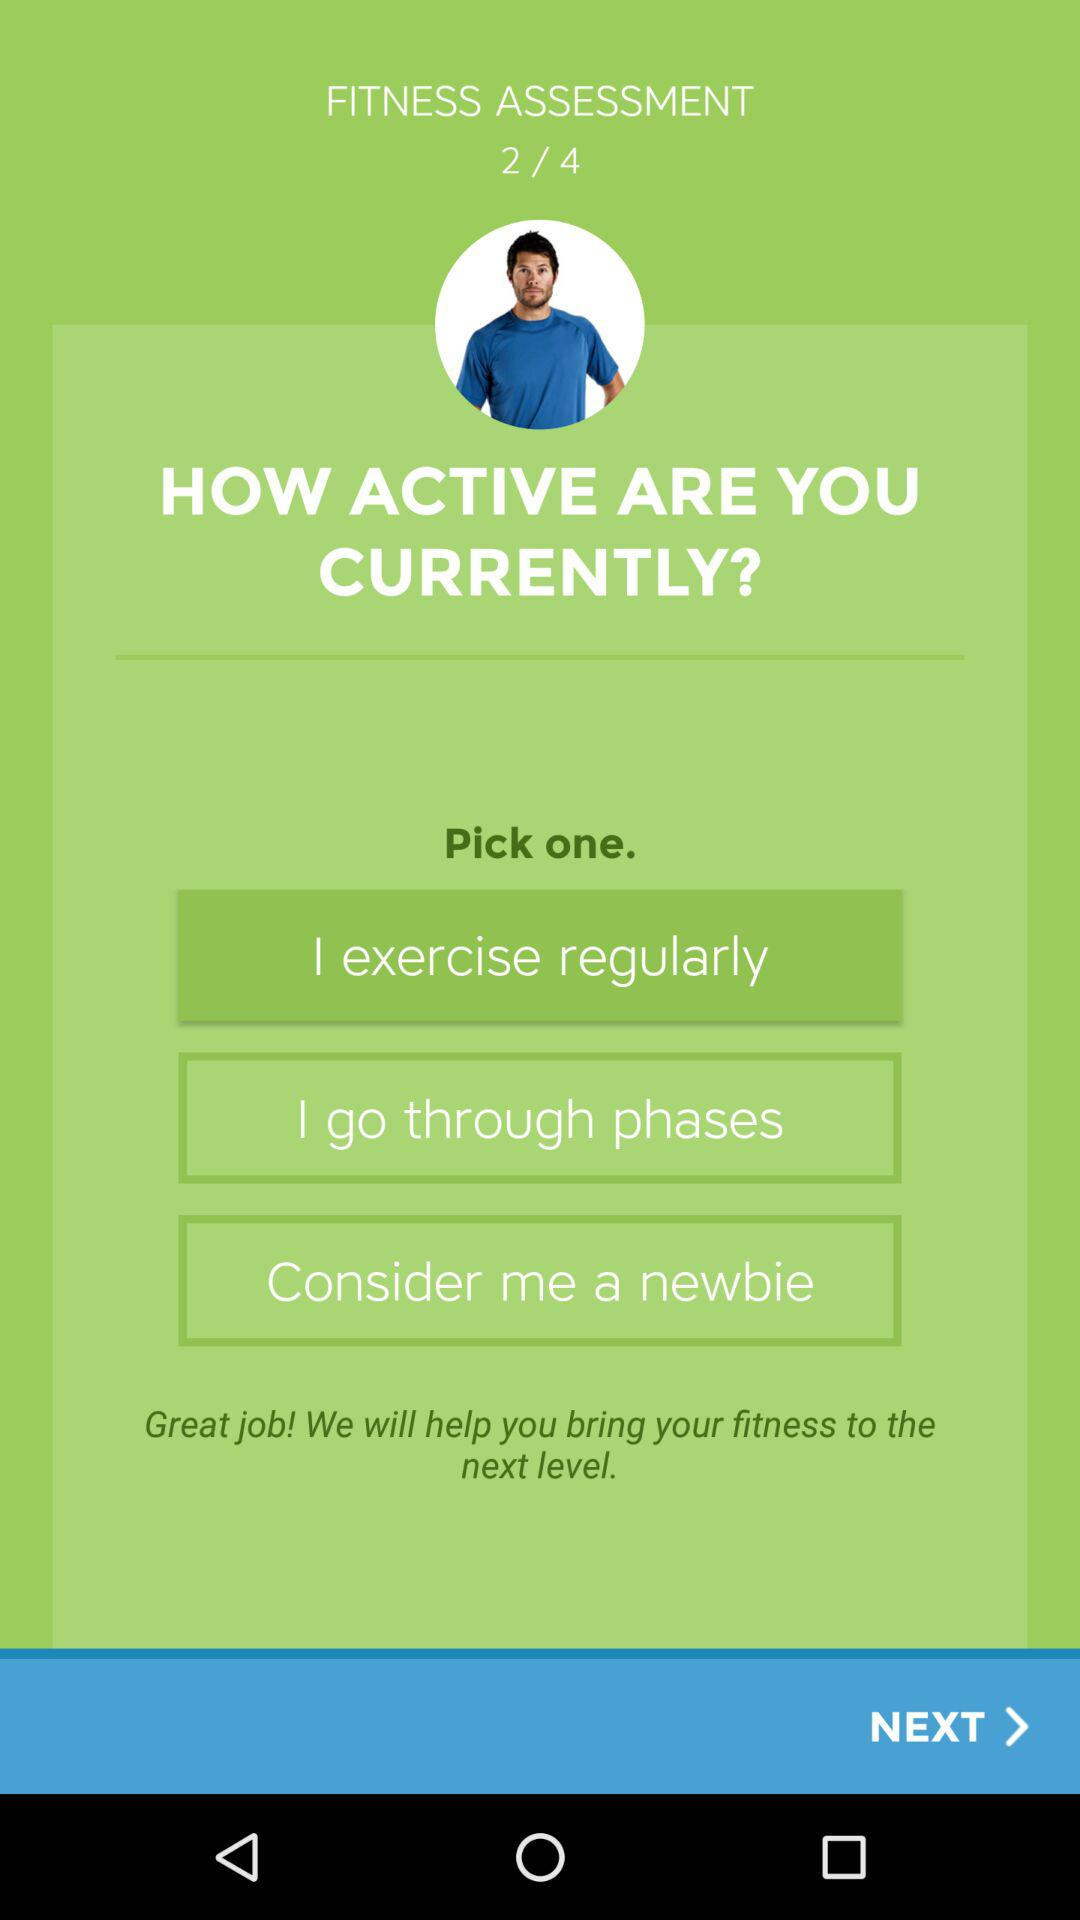What are the choices to pick from? The choices are "I exercise regularly", "I go through phases" and "Consider me a newbie". 